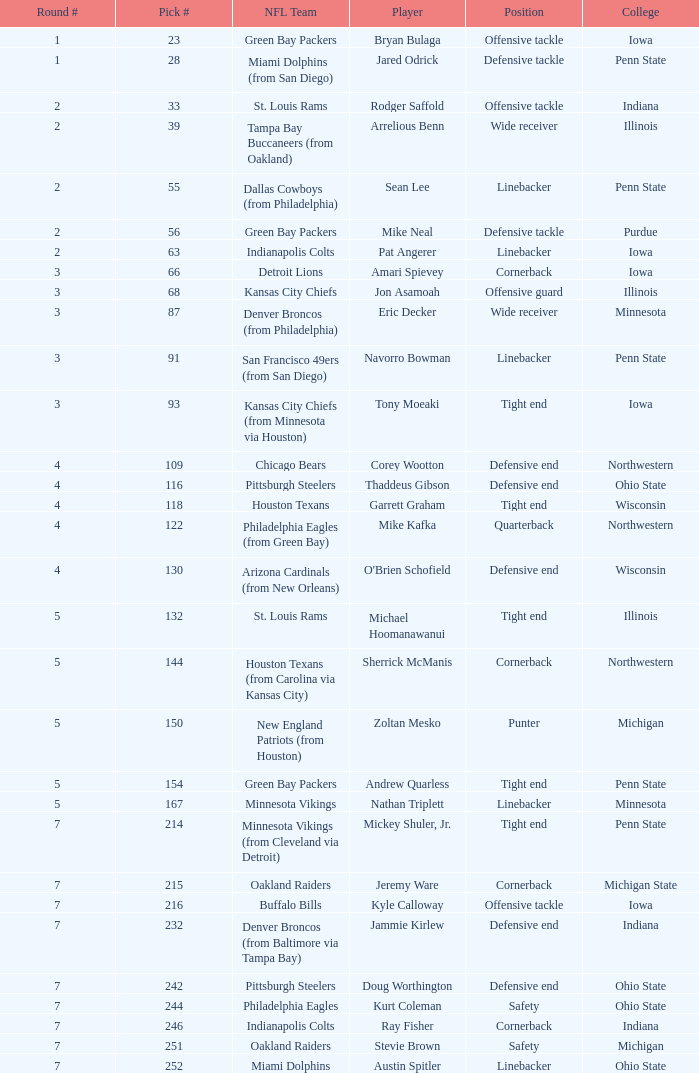Can you parse all the data within this table? {'header': ['Round #', 'Pick #', 'NFL Team', 'Player', 'Position', 'College'], 'rows': [['1', '23', 'Green Bay Packers', 'Bryan Bulaga', 'Offensive tackle', 'Iowa'], ['1', '28', 'Miami Dolphins (from San Diego)', 'Jared Odrick', 'Defensive tackle', 'Penn State'], ['2', '33', 'St. Louis Rams', 'Rodger Saffold', 'Offensive tackle', 'Indiana'], ['2', '39', 'Tampa Bay Buccaneers (from Oakland)', 'Arrelious Benn', 'Wide receiver', 'Illinois'], ['2', '55', 'Dallas Cowboys (from Philadelphia)', 'Sean Lee', 'Linebacker', 'Penn State'], ['2', '56', 'Green Bay Packers', 'Mike Neal', 'Defensive tackle', 'Purdue'], ['2', '63', 'Indianapolis Colts', 'Pat Angerer', 'Linebacker', 'Iowa'], ['3', '66', 'Detroit Lions', 'Amari Spievey', 'Cornerback', 'Iowa'], ['3', '68', 'Kansas City Chiefs', 'Jon Asamoah', 'Offensive guard', 'Illinois'], ['3', '87', 'Denver Broncos (from Philadelphia)', 'Eric Decker', 'Wide receiver', 'Minnesota'], ['3', '91', 'San Francisco 49ers (from San Diego)', 'Navorro Bowman', 'Linebacker', 'Penn State'], ['3', '93', 'Kansas City Chiefs (from Minnesota via Houston)', 'Tony Moeaki', 'Tight end', 'Iowa'], ['4', '109', 'Chicago Bears', 'Corey Wootton', 'Defensive end', 'Northwestern'], ['4', '116', 'Pittsburgh Steelers', 'Thaddeus Gibson', 'Defensive end', 'Ohio State'], ['4', '118', 'Houston Texans', 'Garrett Graham', 'Tight end', 'Wisconsin'], ['4', '122', 'Philadelphia Eagles (from Green Bay)', 'Mike Kafka', 'Quarterback', 'Northwestern'], ['4', '130', 'Arizona Cardinals (from New Orleans)', "O'Brien Schofield", 'Defensive end', 'Wisconsin'], ['5', '132', 'St. Louis Rams', 'Michael Hoomanawanui', 'Tight end', 'Illinois'], ['5', '144', 'Houston Texans (from Carolina via Kansas City)', 'Sherrick McManis', 'Cornerback', 'Northwestern'], ['5', '150', 'New England Patriots (from Houston)', 'Zoltan Mesko', 'Punter', 'Michigan'], ['5', '154', 'Green Bay Packers', 'Andrew Quarless', 'Tight end', 'Penn State'], ['5', '167', 'Minnesota Vikings', 'Nathan Triplett', 'Linebacker', 'Minnesota'], ['7', '214', 'Minnesota Vikings (from Cleveland via Detroit)', 'Mickey Shuler, Jr.', 'Tight end', 'Penn State'], ['7', '215', 'Oakland Raiders', 'Jeremy Ware', 'Cornerback', 'Michigan State'], ['7', '216', 'Buffalo Bills', 'Kyle Calloway', 'Offensive tackle', 'Iowa'], ['7', '232', 'Denver Broncos (from Baltimore via Tampa Bay)', 'Jammie Kirlew', 'Defensive end', 'Indiana'], ['7', '242', 'Pittsburgh Steelers', 'Doug Worthington', 'Defensive end', 'Ohio State'], ['7', '244', 'Philadelphia Eagles', 'Kurt Coleman', 'Safety', 'Ohio State'], ['7', '246', 'Indianapolis Colts', 'Ray Fisher', 'Cornerback', 'Indiana'], ['7', '251', 'Oakland Raiders', 'Stevie Brown', 'Safety', 'Michigan'], ['7', '252', 'Miami Dolphins', 'Austin Spitler', 'Linebacker', 'Ohio State']]} How many NFL teams does Stevie Brown play for? 1.0. 